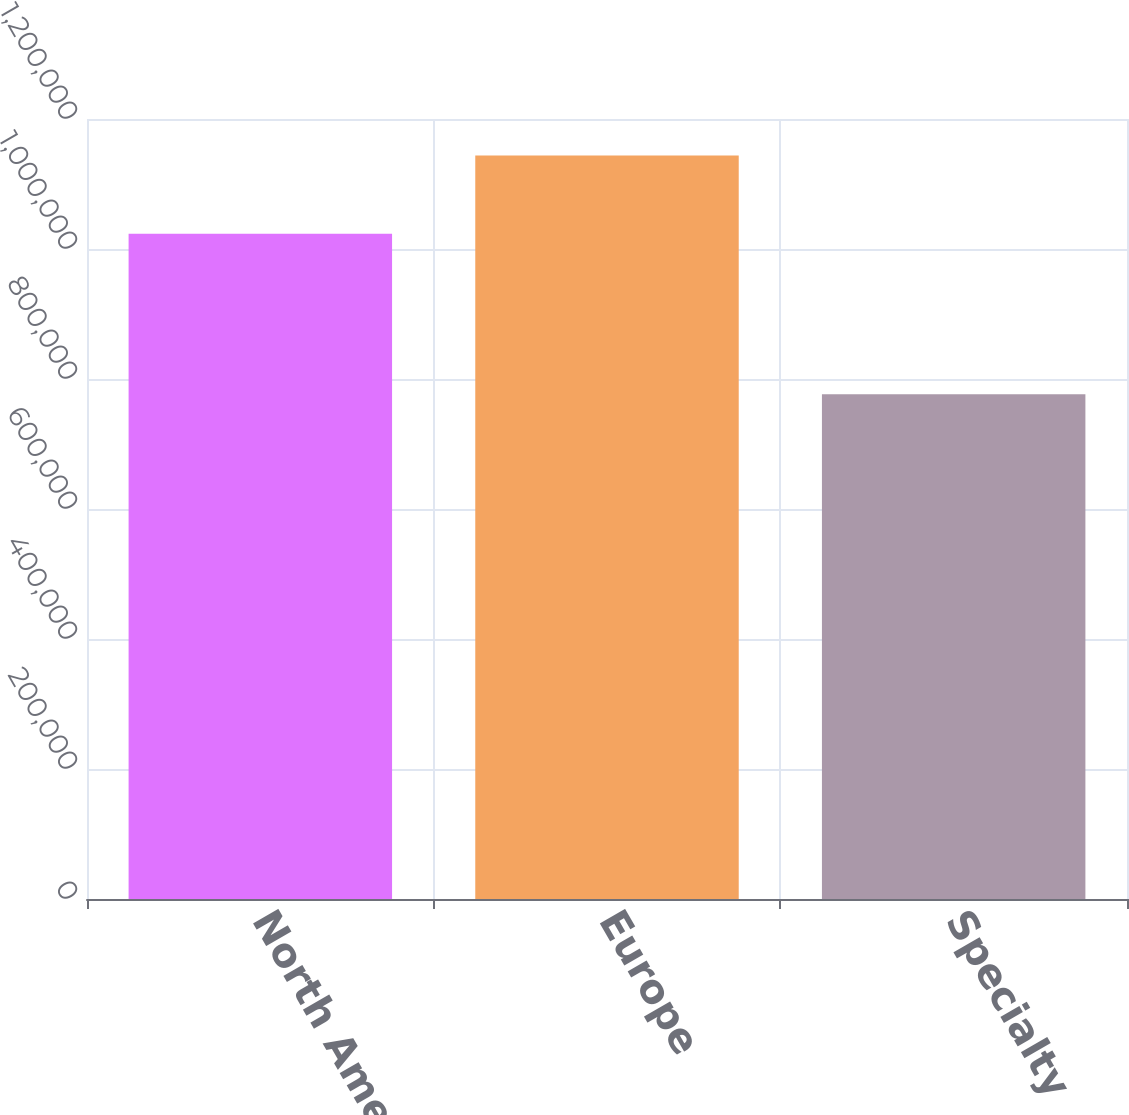<chart> <loc_0><loc_0><loc_500><loc_500><bar_chart><fcel>North America<fcel>Europe<fcel>Specialty<nl><fcel>1.0234e+06<fcel>1.14367e+06<fcel>776611<nl></chart> 